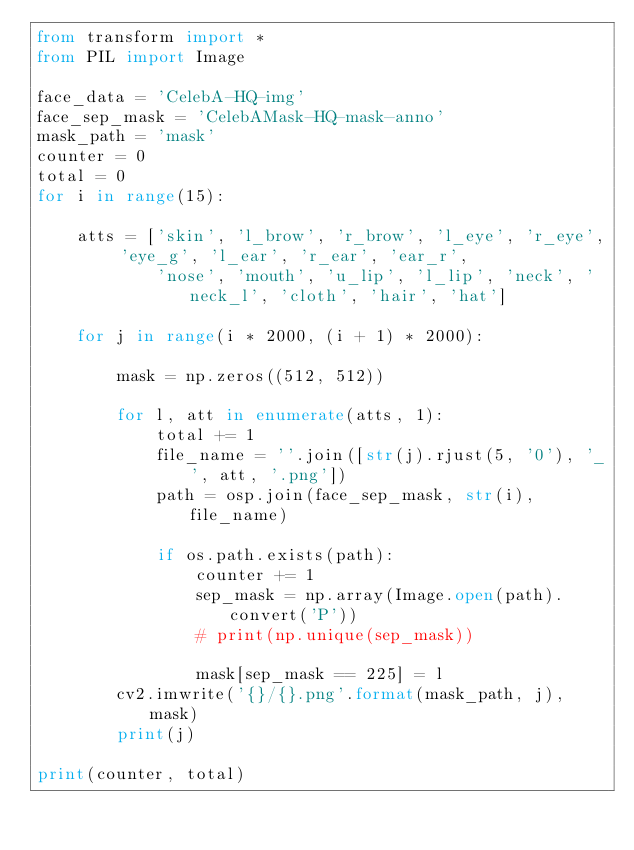Convert code to text. <code><loc_0><loc_0><loc_500><loc_500><_Python_>from transform import *
from PIL import Image

face_data = 'CelebA-HQ-img'
face_sep_mask = 'CelebAMask-HQ-mask-anno'
mask_path = 'mask'
counter = 0
total = 0
for i in range(15):

    atts = ['skin', 'l_brow', 'r_brow', 'l_eye', 'r_eye', 'eye_g', 'l_ear', 'r_ear', 'ear_r',
            'nose', 'mouth', 'u_lip', 'l_lip', 'neck', 'neck_l', 'cloth', 'hair', 'hat']

    for j in range(i * 2000, (i + 1) * 2000):

        mask = np.zeros((512, 512))

        for l, att in enumerate(atts, 1):
            total += 1
            file_name = ''.join([str(j).rjust(5, '0'), '_', att, '.png'])
            path = osp.join(face_sep_mask, str(i), file_name)

            if os.path.exists(path):
                counter += 1
                sep_mask = np.array(Image.open(path).convert('P'))
                # print(np.unique(sep_mask))

                mask[sep_mask == 225] = l
        cv2.imwrite('{}/{}.png'.format(mask_path, j), mask)
        print(j)

print(counter, total)</code> 